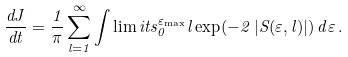<formula> <loc_0><loc_0><loc_500><loc_500>\frac { d J } { d t } = \frac { 1 } { \pi } \sum _ { l = 1 } ^ { \infty } \int \lim i t s ^ { \varepsilon _ { \max } } _ { 0 } l \exp ( - 2 \, | S ( \varepsilon , l ) | ) \, d \varepsilon \, .</formula> 